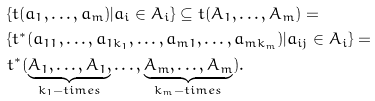Convert formula to latex. <formula><loc_0><loc_0><loc_500><loc_500>& \{ t ( a _ { 1 } , \dots , a _ { m } ) | a _ { i } \in A _ { i } \} \subseteq t ( A _ { 1 } , \dots , A _ { m } ) = \\ & \{ t ^ { * } ( a _ { 1 1 } , \dots , a _ { 1 k _ { 1 } } , \dots , a _ { m 1 } , \dots , a _ { m k _ { m } } ) | a _ { i j } \in A _ { i } \} = \\ & t ^ { * } ( \underbrace { A _ { 1 } , \dots , A _ { 1 } , } _ { k _ { 1 } - t i m e s } \dots , \underbrace { A _ { m } , \dots , A _ { m } } _ { k _ { m } - t i m e s } ) .</formula> 